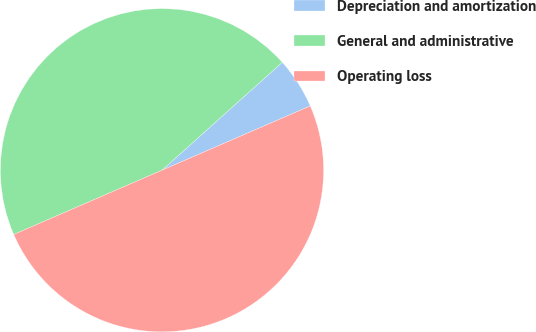<chart> <loc_0><loc_0><loc_500><loc_500><pie_chart><fcel>Depreciation and amortization<fcel>General and administrative<fcel>Operating loss<nl><fcel>5.13%<fcel>44.87%<fcel>50.0%<nl></chart> 